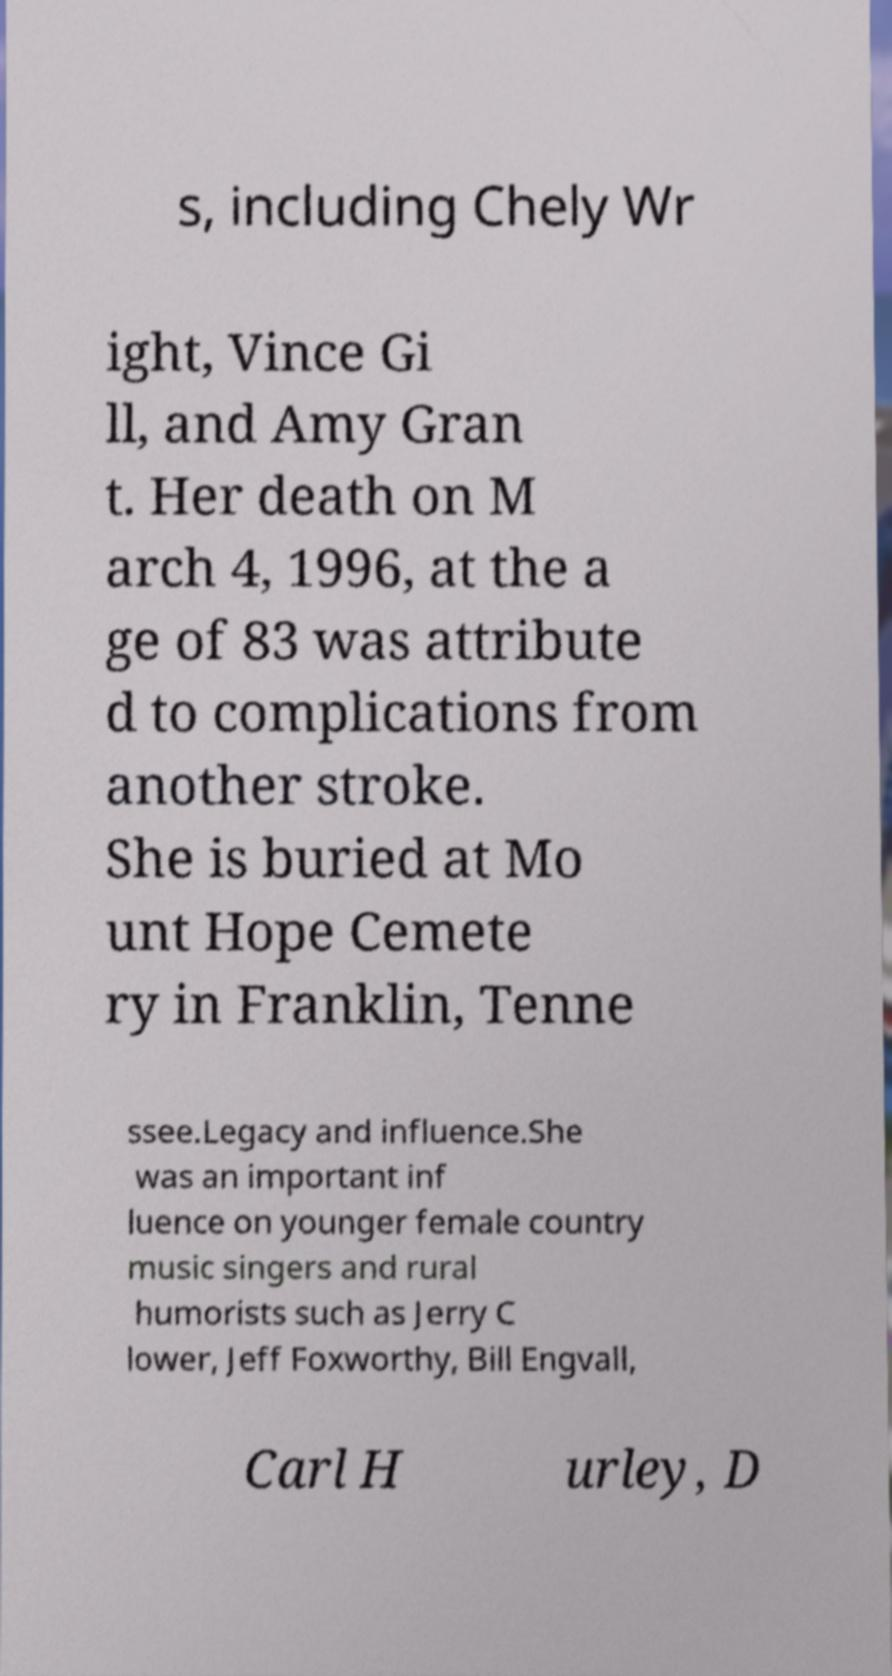Please read and relay the text visible in this image. What does it say? s, including Chely Wr ight, Vince Gi ll, and Amy Gran t. Her death on M arch 4, 1996, at the a ge of 83 was attribute d to complications from another stroke. She is buried at Mo unt Hope Cemete ry in Franklin, Tenne ssee.Legacy and influence.She was an important inf luence on younger female country music singers and rural humorists such as Jerry C lower, Jeff Foxworthy, Bill Engvall, Carl H urley, D 